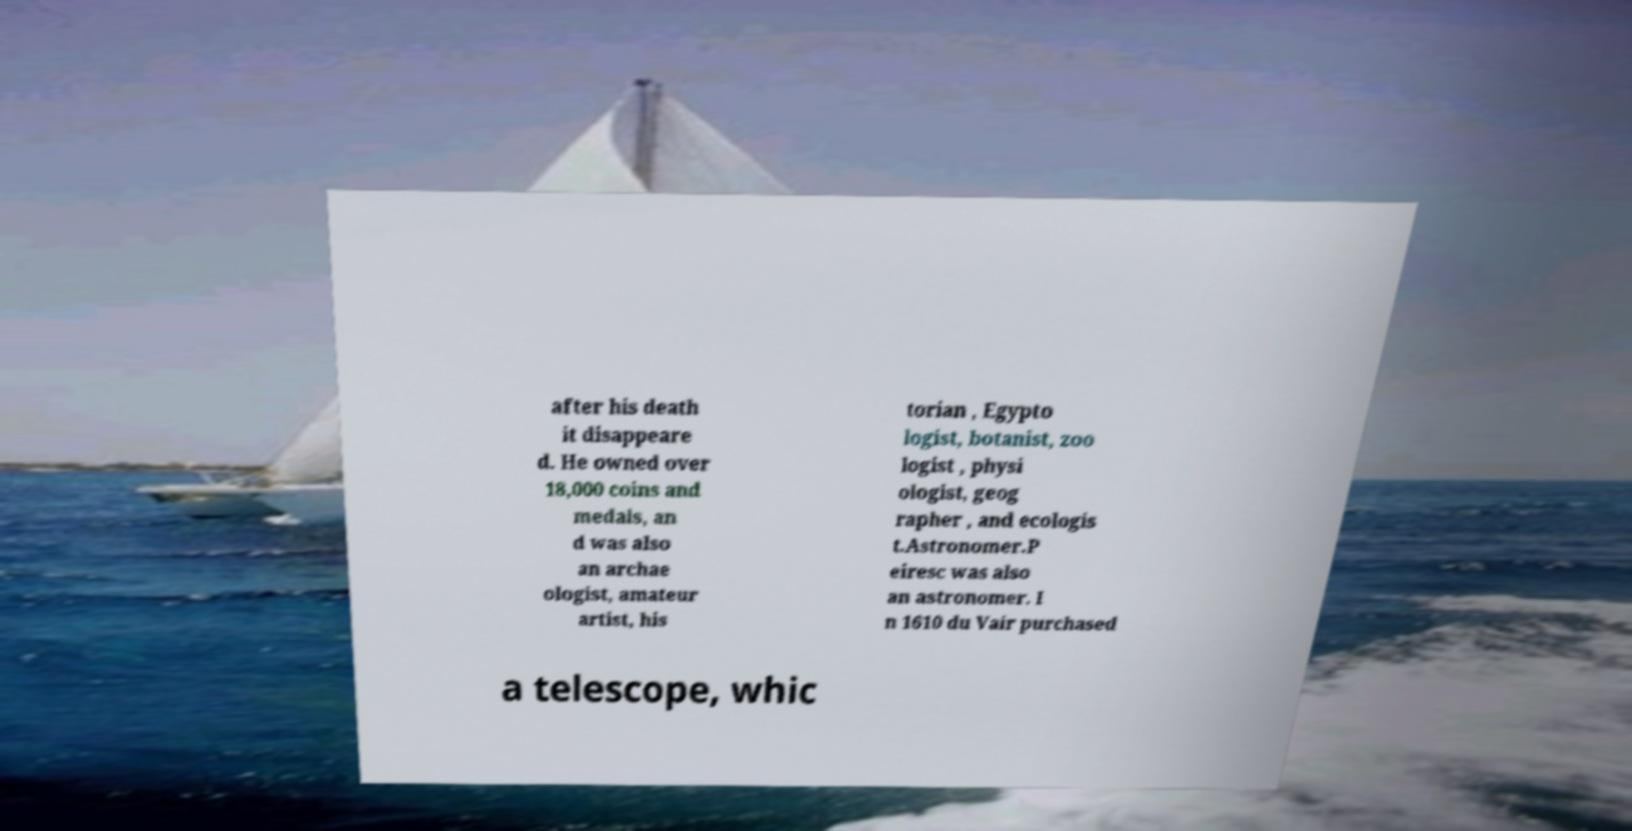Could you assist in decoding the text presented in this image and type it out clearly? after his death it disappeare d. He owned over 18,000 coins and medals, an d was also an archae ologist, amateur artist, his torian , Egypto logist, botanist, zoo logist , physi ologist, geog rapher , and ecologis t.Astronomer.P eiresc was also an astronomer. I n 1610 du Vair purchased a telescope, whic 